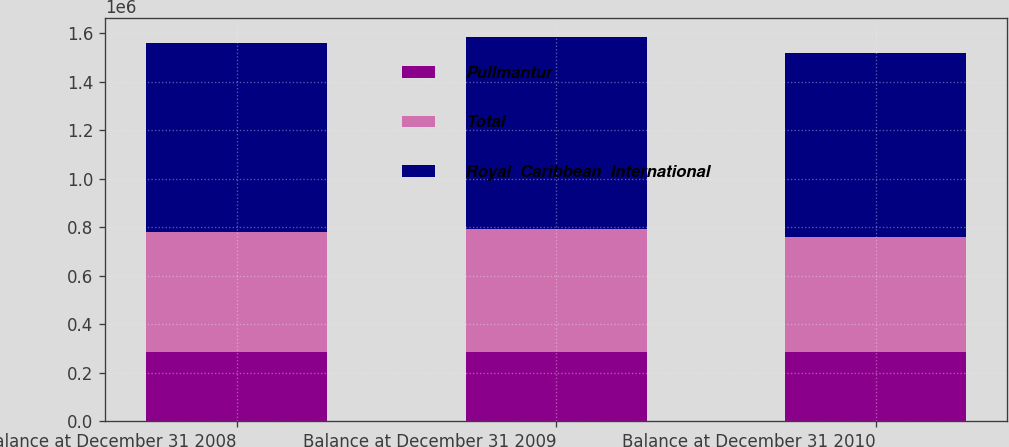Convert chart to OTSL. <chart><loc_0><loc_0><loc_500><loc_500><stacked_bar_chart><ecel><fcel>Balance at December 31 2008<fcel>Balance at December 31 2009<fcel>Balance at December 31 2010<nl><fcel>Pullmantur<fcel>283723<fcel>283723<fcel>283723<nl><fcel>Total<fcel>495523<fcel>508650<fcel>475605<nl><fcel>Royal  Caribbean  International<fcel>779246<fcel>792373<fcel>759328<nl></chart> 